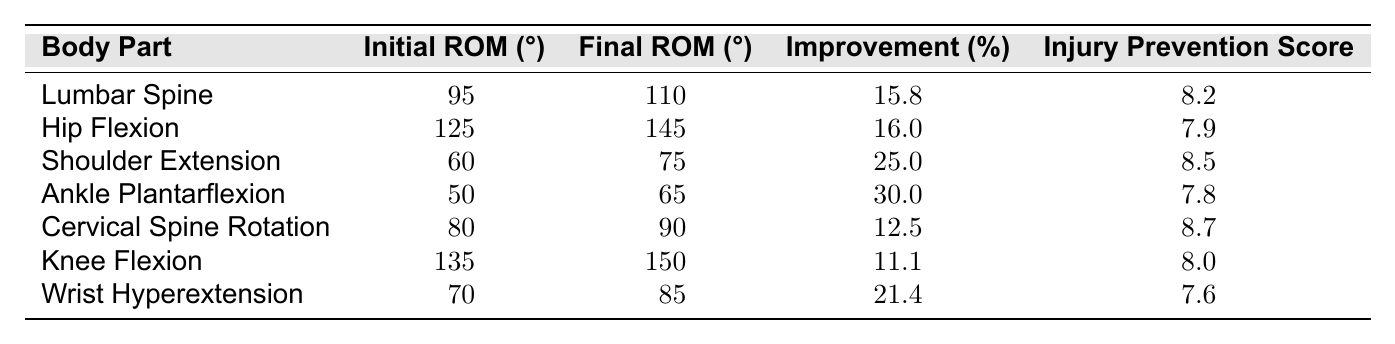What is the average improvement percentage across all body parts? To find the average improvement percentage, we need to add the improvement percentages for all body parts: (15.8 + 16.0 + 25.0 + 30.0 + 12.5 + 11.1 + 21.4) = 132.8. There are 7 body parts, so we divide the total by 7: 132.8 / 7 = 18.97.
Answer: 18.97 Which body part experienced the greatest improvement in range of motion? We compare the improvement percentages for all body parts. The greatest percentage of improvement is 30.0% observed in Ankle Plantarflexion.
Answer: Ankle Plantarflexion What is the injury prevention score for the Hip Flexion? We can directly find this information in the table where Hip Flexion is listed. The injury prevention score for Hip Flexion is 7.9.
Answer: 7.9 Is there a body part that improved its range of motion by more than 20%? We check the improvement percentages: Shoulder Extension has 25.0% and Ankle Plantarflexion has 30.0%, both of which are greater than 20%. Therefore, the answer is yes.
Answer: Yes What is the difference in initial range of motion between Knee Flexion and Lumbar Spine? The initial range of motion for Knee Flexion is 135 degrees and for Lumbar Spine is 95 degrees. The difference is 135 - 95 = 40 degrees.
Answer: 40 degrees Which body part had the highest final range of motion? We look at the final ROM values: Lumbar Spine has 110, Hip Flexion has 145, Shoulder Extension has 75, Ankle Plantarflexion has 65, Cervical Spine Rotation has 90, Knee Flexion has 150, and Wrist Hyperextension has 85 degrees. The highest is 150 degrees for Knee Flexion.
Answer: Knee Flexion What body part had the lowest injury prevention score? By examining the injury prevention scores in the table, we see that the lowest score is 7.6 for Wrist Hyperextension.
Answer: Wrist Hyperextension Calculate the average initial range of motion for the listed body parts. The initial ranges of motion are 95, 125, 60, 50, 80, 135, and 70. First, sum them: 95 + 125 + 60 + 50 + 80 + 135 + 70 = 615. There are 7 body parts, so we divide 615 by 7: 615 / 7 = 87.86.
Answer: 87.86 Which body parts had an injury prevention score above 8? We check the injury prevention scores: Lumbar Spine (8.2), Shoulder Extension (8.5), and Cervical Spine Rotation (8.7) all have scores above 8. Thus, three body parts qualify.
Answer: 3 body parts Determine the total improvement percentage for all listed body parts combined. We sum all improvement percentages: 15.8 + 16.0 + 25.0 + 30.0 + 12.5 + 11.1 + 21.4 = 132.8%.
Answer: 132.8% 